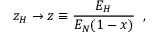<formula> <loc_0><loc_0><loc_500><loc_500>z _ { H } \rightarrow z \equiv \frac { E _ { H } } { E _ { N } ( 1 - x ) } \, ,</formula> 